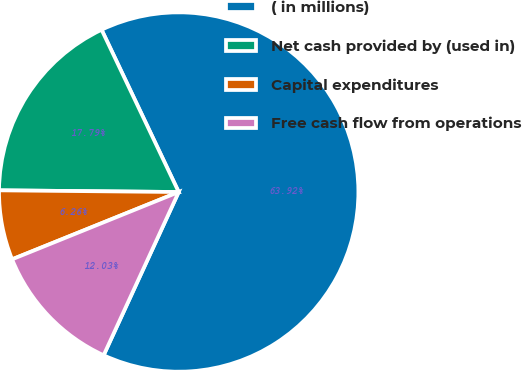Convert chart. <chart><loc_0><loc_0><loc_500><loc_500><pie_chart><fcel>( in millions)<fcel>Net cash provided by (used in)<fcel>Capital expenditures<fcel>Free cash flow from operations<nl><fcel>63.92%<fcel>17.79%<fcel>6.26%<fcel>12.03%<nl></chart> 